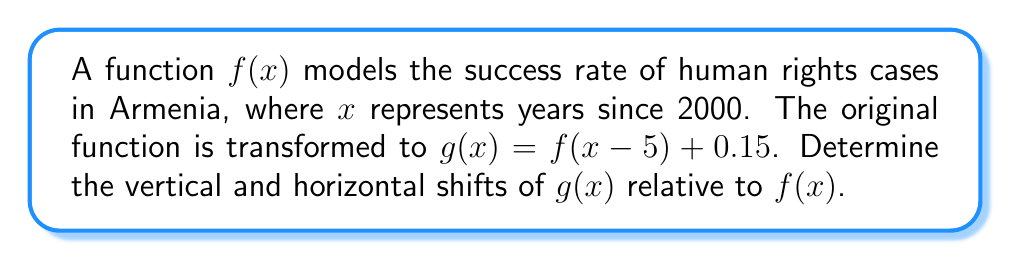Show me your answer to this math problem. To determine the vertical and horizontal shifts of $g(x)$ relative to $f(x)$, we need to analyze the transformation applied to $f(x)$.

1. The general form of a transformed function with vertical and horizontal shifts is:
   $$g(x) = f(x - h) + k$$
   where $h$ represents the horizontal shift and $k$ represents the vertical shift.

2. In our case, $g(x) = f(x-5) + 0.15$

3. Comparing this to the general form:
   - The term inside the parentheses is $(x-5)$, so $h = 5$
   - The term added outside the function is $0.15$, so $k = 0.15$

4. Horizontal shift:
   - When $h$ is positive, the graph shifts $h$ units to the right
   - Here, $h = 5$, so the graph shifts 5 units to the right

5. Vertical shift:
   - When $k$ is positive, the graph shifts $k$ units up
   - Here, $k = 0.15$, so the graph shifts 0.15 units up

Therefore, $g(x)$ is shifted 5 units right and 0.15 units up relative to $f(x)$.
Answer: 5 units right, 0.15 units up 